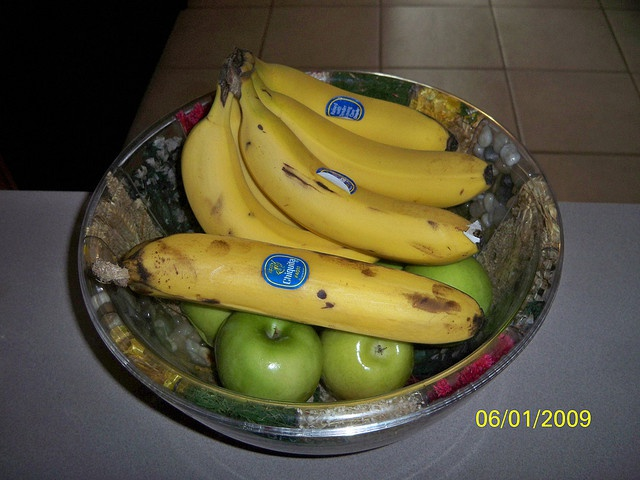Describe the objects in this image and their specific colors. I can see bowl in black and olive tones, banana in black, olive, and tan tones, banana in black, olive, and tan tones, apple in black, darkgreen, and olive tones, and banana in black, olive, and tan tones in this image. 